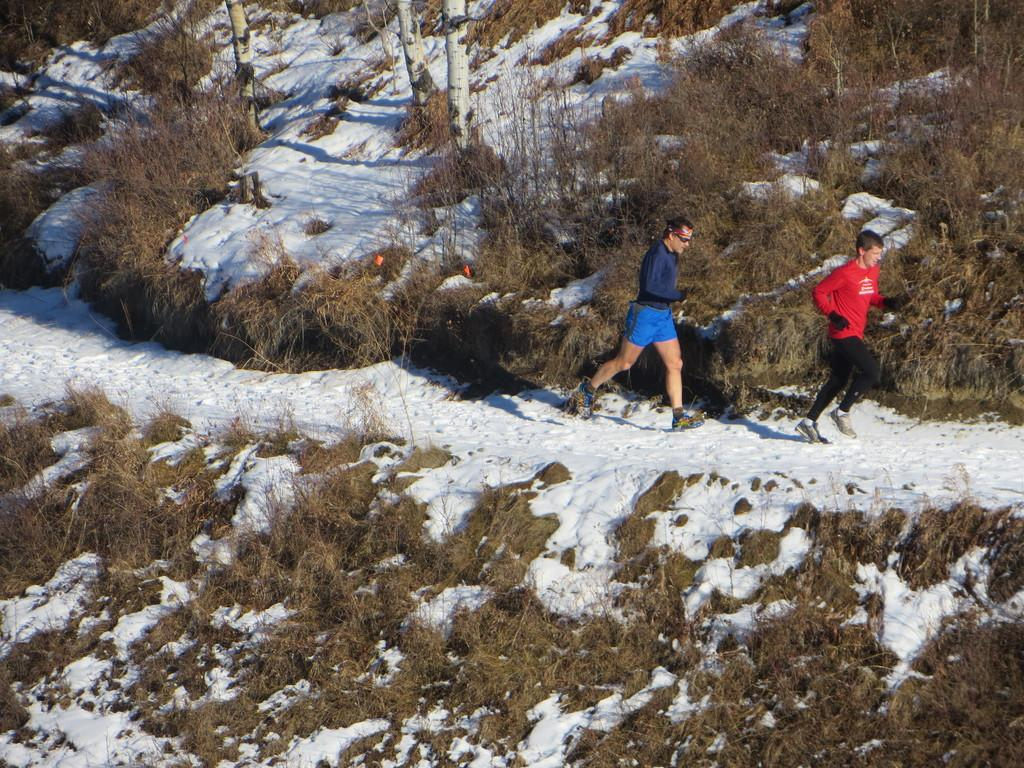How many people are in the image? There are two persons in the image. What are the persons doing in the image? The persons are running. What is the condition of the ground in the image? The ground has snow. What type of vegetation is present on the ground? There are plants and trees on the ground. What type of cough medicine is the person holding in the image? There is no cough medicine or any indication of a cough in the image. 